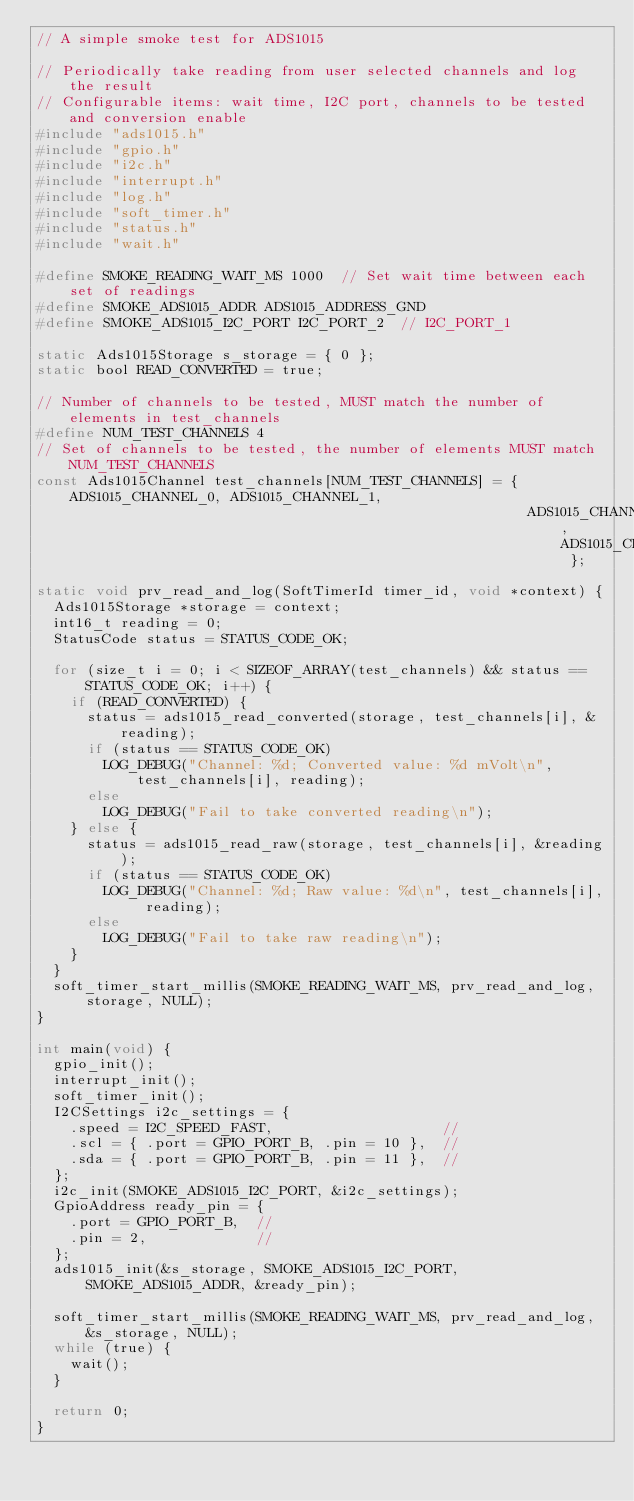<code> <loc_0><loc_0><loc_500><loc_500><_C_>// A simple smoke test for ADS1015

// Periodically take reading from user selected channels and log the result
// Configurable items: wait time, I2C port, channels to be tested and conversion enable
#include "ads1015.h"
#include "gpio.h"
#include "i2c.h"
#include "interrupt.h"
#include "log.h"
#include "soft_timer.h"
#include "status.h"
#include "wait.h"

#define SMOKE_READING_WAIT_MS 1000  // Set wait time between each set of readings
#define SMOKE_ADS1015_ADDR ADS1015_ADDRESS_GND
#define SMOKE_ADS1015_I2C_PORT I2C_PORT_2  // I2C_PORT_1

static Ads1015Storage s_storage = { 0 };
static bool READ_CONVERTED = true;

// Number of channels to be tested, MUST match the number of elements in test_channels
#define NUM_TEST_CHANNELS 4
// Set of channels to be tested, the number of elements MUST match NUM_TEST_CHANNELS
const Ads1015Channel test_channels[NUM_TEST_CHANNELS] = { ADS1015_CHANNEL_0, ADS1015_CHANNEL_1,
                                                          ADS1015_CHANNEL_2, ADS1015_CHANNEL_3 };

static void prv_read_and_log(SoftTimerId timer_id, void *context) {
  Ads1015Storage *storage = context;
  int16_t reading = 0;
  StatusCode status = STATUS_CODE_OK;

  for (size_t i = 0; i < SIZEOF_ARRAY(test_channels) && status == STATUS_CODE_OK; i++) {
    if (READ_CONVERTED) {
      status = ads1015_read_converted(storage, test_channels[i], &reading);
      if (status == STATUS_CODE_OK)
        LOG_DEBUG("Channel: %d; Converted value: %d mVolt\n", test_channels[i], reading);
      else
        LOG_DEBUG("Fail to take converted reading\n");
    } else {
      status = ads1015_read_raw(storage, test_channels[i], &reading);
      if (status == STATUS_CODE_OK)
        LOG_DEBUG("Channel: %d; Raw value: %d\n", test_channels[i], reading);
      else
        LOG_DEBUG("Fail to take raw reading\n");
    }
  }
  soft_timer_start_millis(SMOKE_READING_WAIT_MS, prv_read_and_log, storage, NULL);
}

int main(void) {
  gpio_init();
  interrupt_init();
  soft_timer_init();
  I2CSettings i2c_settings = {
    .speed = I2C_SPEED_FAST,                    //
    .scl = { .port = GPIO_PORT_B, .pin = 10 },  //
    .sda = { .port = GPIO_PORT_B, .pin = 11 },  //
  };
  i2c_init(SMOKE_ADS1015_I2C_PORT, &i2c_settings);
  GpioAddress ready_pin = {
    .port = GPIO_PORT_B,  //
    .pin = 2,             //
  };
  ads1015_init(&s_storage, SMOKE_ADS1015_I2C_PORT, SMOKE_ADS1015_ADDR, &ready_pin);

  soft_timer_start_millis(SMOKE_READING_WAIT_MS, prv_read_and_log, &s_storage, NULL);
  while (true) {
    wait();
  }

  return 0;
}
</code> 